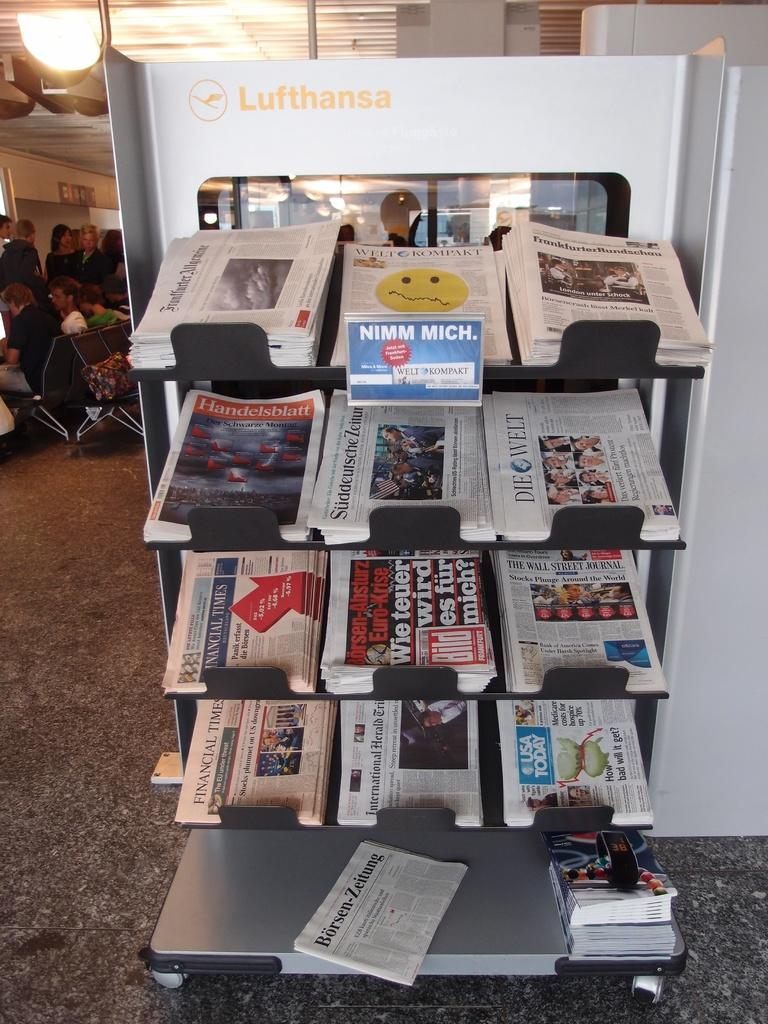Provide a one-sentence caption for the provided image. A newspaper stand with 12 different papers and a sign that states NUMM MICH. 